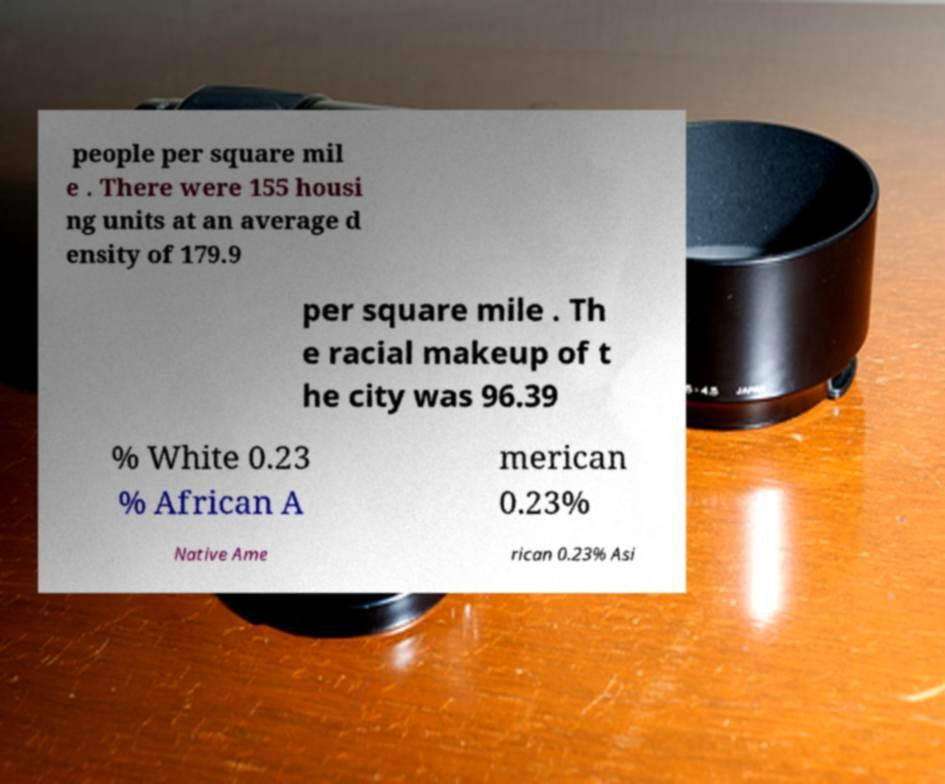What messages or text are displayed in this image? I need them in a readable, typed format. people per square mil e . There were 155 housi ng units at an average d ensity of 179.9 per square mile . Th e racial makeup of t he city was 96.39 % White 0.23 % African A merican 0.23% Native Ame rican 0.23% Asi 